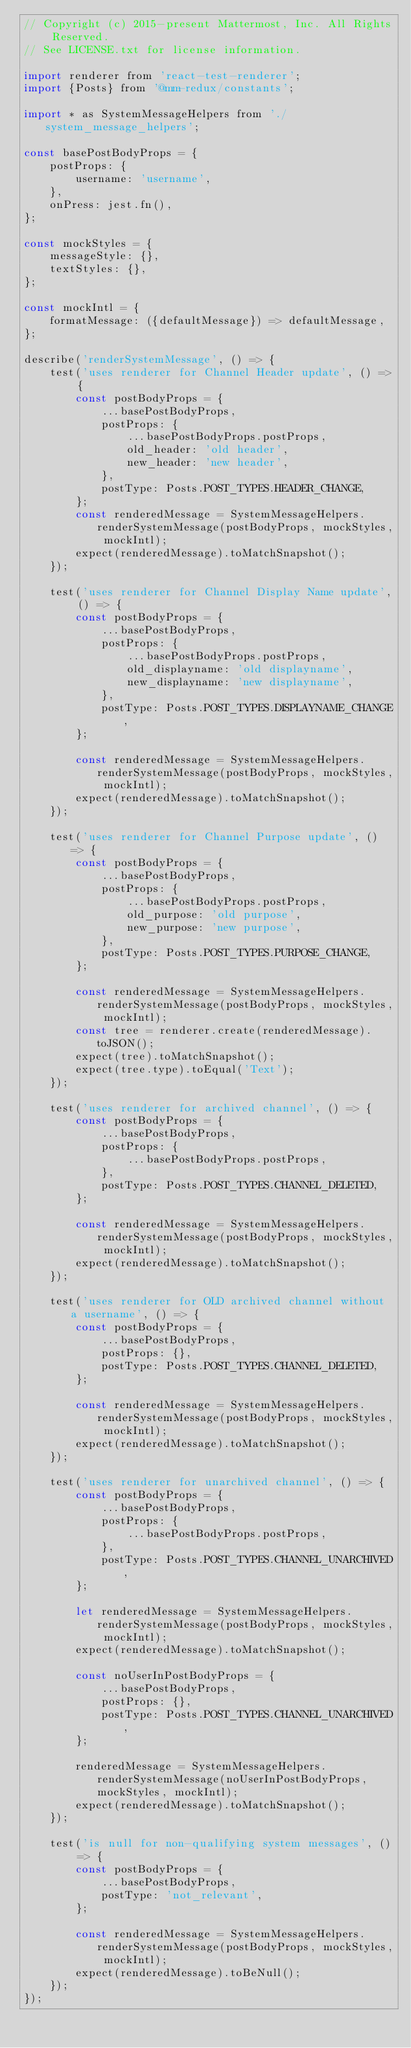Convert code to text. <code><loc_0><loc_0><loc_500><loc_500><_JavaScript_>// Copyright (c) 2015-present Mattermost, Inc. All Rights Reserved.
// See LICENSE.txt for license information.

import renderer from 'react-test-renderer';
import {Posts} from '@mm-redux/constants';

import * as SystemMessageHelpers from './system_message_helpers';

const basePostBodyProps = {
    postProps: {
        username: 'username',
    },
    onPress: jest.fn(),
};

const mockStyles = {
    messageStyle: {},
    textStyles: {},
};

const mockIntl = {
    formatMessage: ({defaultMessage}) => defaultMessage,
};

describe('renderSystemMessage', () => {
    test('uses renderer for Channel Header update', () => {
        const postBodyProps = {
            ...basePostBodyProps,
            postProps: {
                ...basePostBodyProps.postProps,
                old_header: 'old header',
                new_header: 'new header',
            },
            postType: Posts.POST_TYPES.HEADER_CHANGE,
        };
        const renderedMessage = SystemMessageHelpers.renderSystemMessage(postBodyProps, mockStyles, mockIntl);
        expect(renderedMessage).toMatchSnapshot();
    });

    test('uses renderer for Channel Display Name update', () => {
        const postBodyProps = {
            ...basePostBodyProps,
            postProps: {
                ...basePostBodyProps.postProps,
                old_displayname: 'old displayname',
                new_displayname: 'new displayname',
            },
            postType: Posts.POST_TYPES.DISPLAYNAME_CHANGE,
        };

        const renderedMessage = SystemMessageHelpers.renderSystemMessage(postBodyProps, mockStyles, mockIntl);
        expect(renderedMessage).toMatchSnapshot();
    });

    test('uses renderer for Channel Purpose update', () => {
        const postBodyProps = {
            ...basePostBodyProps,
            postProps: {
                ...basePostBodyProps.postProps,
                old_purpose: 'old purpose',
                new_purpose: 'new purpose',
            },
            postType: Posts.POST_TYPES.PURPOSE_CHANGE,
        };

        const renderedMessage = SystemMessageHelpers.renderSystemMessage(postBodyProps, mockStyles, mockIntl);
        const tree = renderer.create(renderedMessage).toJSON();
        expect(tree).toMatchSnapshot();
        expect(tree.type).toEqual('Text');
    });

    test('uses renderer for archived channel', () => {
        const postBodyProps = {
            ...basePostBodyProps,
            postProps: {
                ...basePostBodyProps.postProps,
            },
            postType: Posts.POST_TYPES.CHANNEL_DELETED,
        };

        const renderedMessage = SystemMessageHelpers.renderSystemMessage(postBodyProps, mockStyles, mockIntl);
        expect(renderedMessage).toMatchSnapshot();
    });

    test('uses renderer for OLD archived channel without a username', () => {
        const postBodyProps = {
            ...basePostBodyProps,
            postProps: {},
            postType: Posts.POST_TYPES.CHANNEL_DELETED,
        };

        const renderedMessage = SystemMessageHelpers.renderSystemMessage(postBodyProps, mockStyles, mockIntl);
        expect(renderedMessage).toMatchSnapshot();
    });

    test('uses renderer for unarchived channel', () => {
        const postBodyProps = {
            ...basePostBodyProps,
            postProps: {
                ...basePostBodyProps.postProps,
            },
            postType: Posts.POST_TYPES.CHANNEL_UNARCHIVED,
        };

        let renderedMessage = SystemMessageHelpers.renderSystemMessage(postBodyProps, mockStyles, mockIntl);
        expect(renderedMessage).toMatchSnapshot();

        const noUserInPostBodyProps = {
            ...basePostBodyProps,
            postProps: {},
            postType: Posts.POST_TYPES.CHANNEL_UNARCHIVED,
        };

        renderedMessage = SystemMessageHelpers.renderSystemMessage(noUserInPostBodyProps, mockStyles, mockIntl);
        expect(renderedMessage).toMatchSnapshot();
    });

    test('is null for non-qualifying system messages', () => {
        const postBodyProps = {
            ...basePostBodyProps,
            postType: 'not_relevant',
        };

        const renderedMessage = SystemMessageHelpers.renderSystemMessage(postBodyProps, mockStyles, mockIntl);
        expect(renderedMessage).toBeNull();
    });
});
</code> 